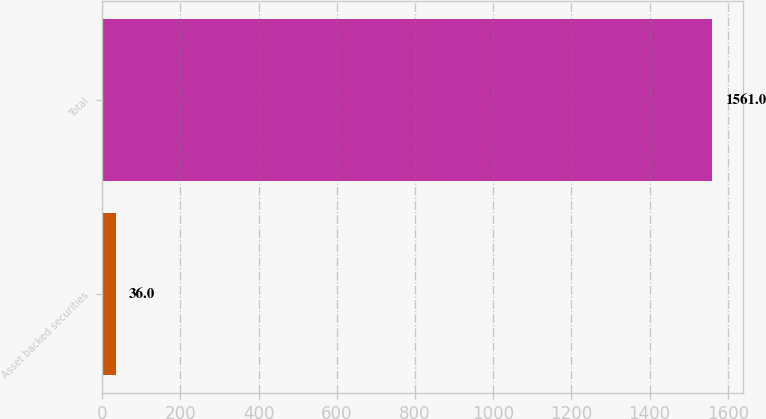Convert chart. <chart><loc_0><loc_0><loc_500><loc_500><bar_chart><fcel>Asset backed securities<fcel>Total<nl><fcel>36<fcel>1561<nl></chart> 